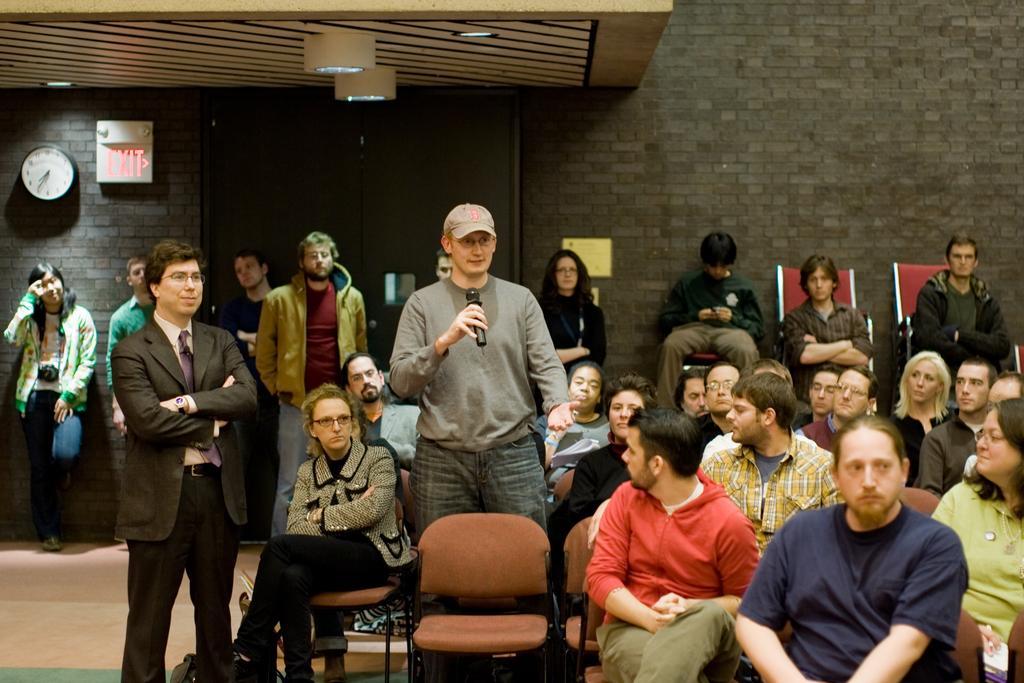Could you give a brief overview of what you see in this image? In this image I can see people were few are standing and few are sitting on chairs. I can see here a man is holding a mic and wearing a cap. I can also see most of them wearing jacket. In the background I can see a clock, few lights and a exit board. 